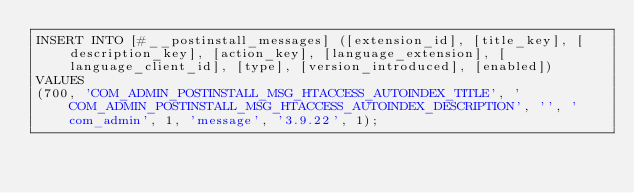Convert code to text. <code><loc_0><loc_0><loc_500><loc_500><_SQL_>INSERT INTO [#__postinstall_messages] ([extension_id], [title_key], [description_key], [action_key], [language_extension], [language_client_id], [type], [version_introduced], [enabled])
VALUES
(700, 'COM_ADMIN_POSTINSTALL_MSG_HTACCESS_AUTOINDEX_TITLE', 'COM_ADMIN_POSTINSTALL_MSG_HTACCESS_AUTOINDEX_DESCRIPTION', '', 'com_admin', 1, 'message', '3.9.22', 1);
</code> 